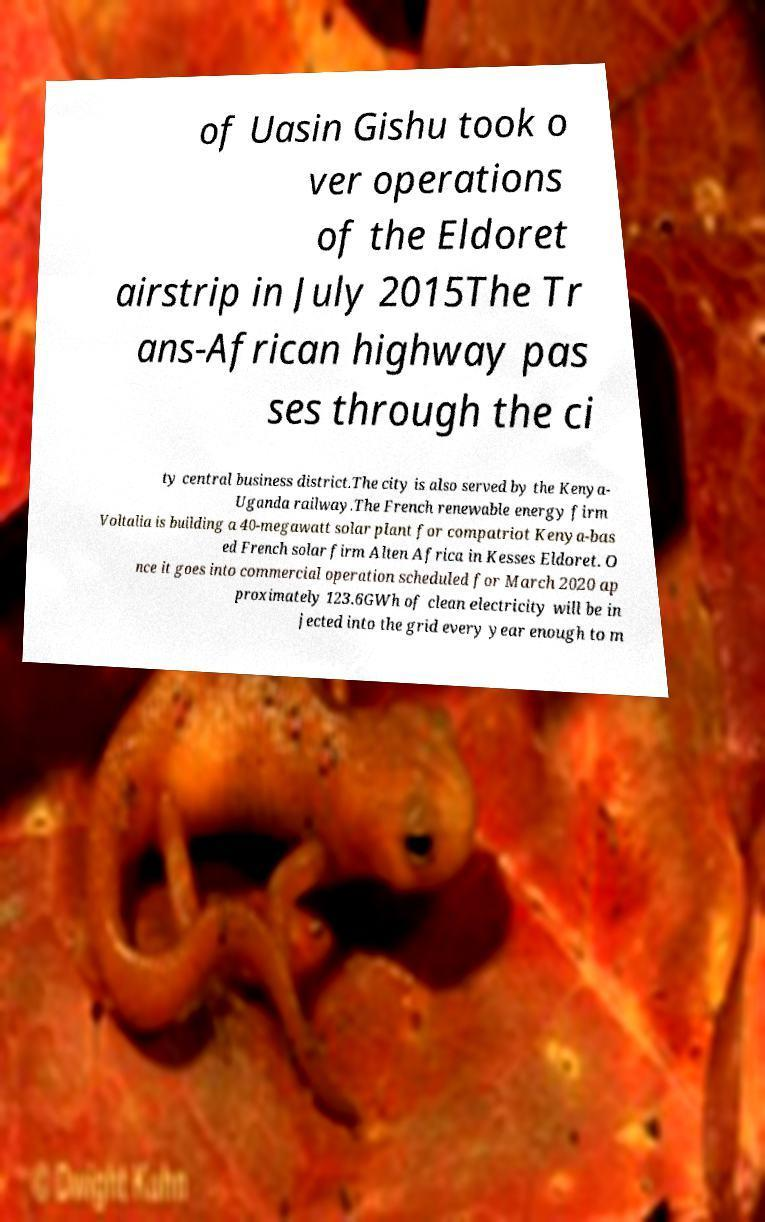Could you assist in decoding the text presented in this image and type it out clearly? of Uasin Gishu took o ver operations of the Eldoret airstrip in July 2015The Tr ans-African highway pas ses through the ci ty central business district.The city is also served by the Kenya- Uganda railway.The French renewable energy firm Voltalia is building a 40-megawatt solar plant for compatriot Kenya-bas ed French solar firm Alten Africa in Kesses Eldoret. O nce it goes into commercial operation scheduled for March 2020 ap proximately 123.6GWh of clean electricity will be in jected into the grid every year enough to m 